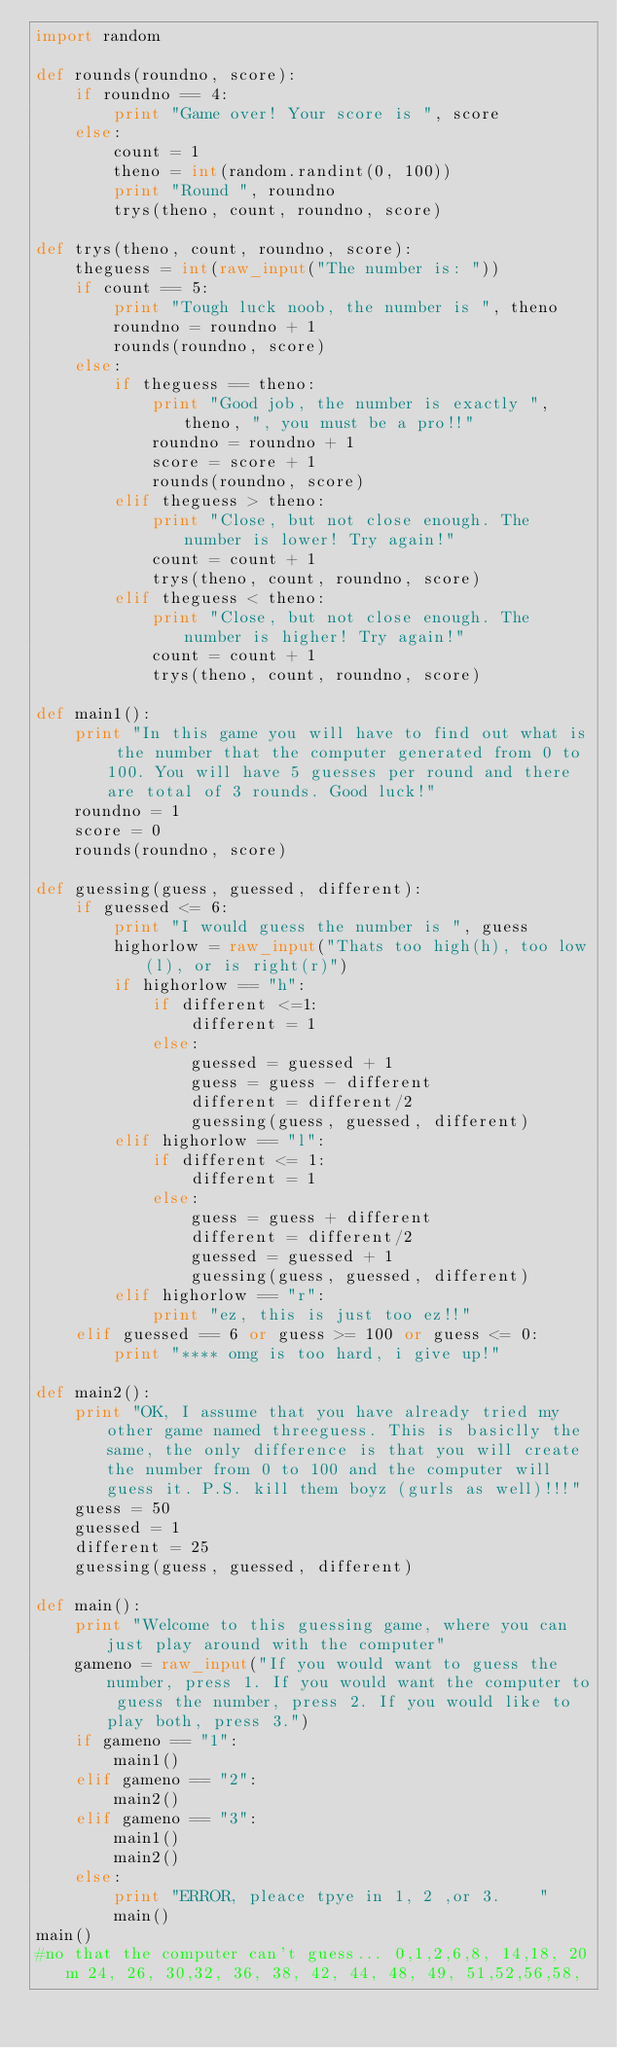Convert code to text. <code><loc_0><loc_0><loc_500><loc_500><_Python_>import random

def rounds(roundno, score):
    if roundno == 4:
        print "Game over! Your score is ", score
    else:
        count = 1
        theno = int(random.randint(0, 100))
        print "Round ", roundno
        trys(theno, count, roundno, score)

def trys(theno, count, roundno, score):
    theguess = int(raw_input("The number is: "))
    if count == 5:
        print "Tough luck noob, the number is ", theno
        roundno = roundno + 1
        rounds(roundno, score)
    else:
        if theguess == theno:
            print "Good job, the number is exactly ", theno, ", you must be a pro!!"
            roundno = roundno + 1
            score = score + 1
            rounds(roundno, score)
        elif theguess > theno:
            print "Close, but not close enough. The number is lower! Try again!"
            count = count + 1
            trys(theno, count, roundno, score)
        elif theguess < theno:
            print "Close, but not close enough. The number is higher! Try again!"
            count = count + 1
            trys(theno, count, roundno, score)

def main1():
    print "In this game you will have to find out what is the number that the computer generated from 0 to 100. You will have 5 guesses per round and there are total of 3 rounds. Good luck!"
    roundno = 1
    score = 0
    rounds(roundno, score)

def guessing(guess, guessed, different):
    if guessed <= 6:
        print "I would guess the number is ", guess
        highorlow = raw_input("Thats too high(h), too low(l), or is right(r)")
        if highorlow == "h":
            if different <=1:
                different = 1
            else:
                guessed = guessed + 1
                guess = guess - different
                different = different/2
                guessing(guess, guessed, different)
        elif highorlow == "l":
            if different <= 1:
                different = 1
            else:
                guess = guess + different
                different = different/2
                guessed = guessed + 1
                guessing(guess, guessed, different)
        elif highorlow == "r":
            print "ez, this is just too ez!!"
    elif guessed == 6 or guess >= 100 or guess <= 0:
        print "**** omg is too hard, i give up!"

def main2():
    print "OK, I assume that you have already tried my other game named threeguess. This is basiclly the same, the only difference is that you will create the number from 0 to 100 and the computer will guess it. P.S. kill them boyz (gurls as well)!!!"
    guess = 50
    guessed = 1
    different = 25
    guessing(guess, guessed, different)

def main():
    print "Welcome to this guessing game, where you can just play around with the computer"
    gameno = raw_input("If you would want to guess the number, press 1. If you would want the computer to guess the number, press 2. If you would like to play both, press 3.")
    if gameno == "1":
        main1()
    elif gameno == "2":
        main2()
    elif gameno == "3":
        main1()
        main2()
    else:
        print "ERROR, pleace tpye in 1, 2 ,or 3.    "
        main()
main()
#no that the computer can't guess... 0,1,2,6,8, 14,18, 20m 24, 26, 30,32, 36, 38, 42, 44, 48, 49, 51,52,56,58, 

</code> 